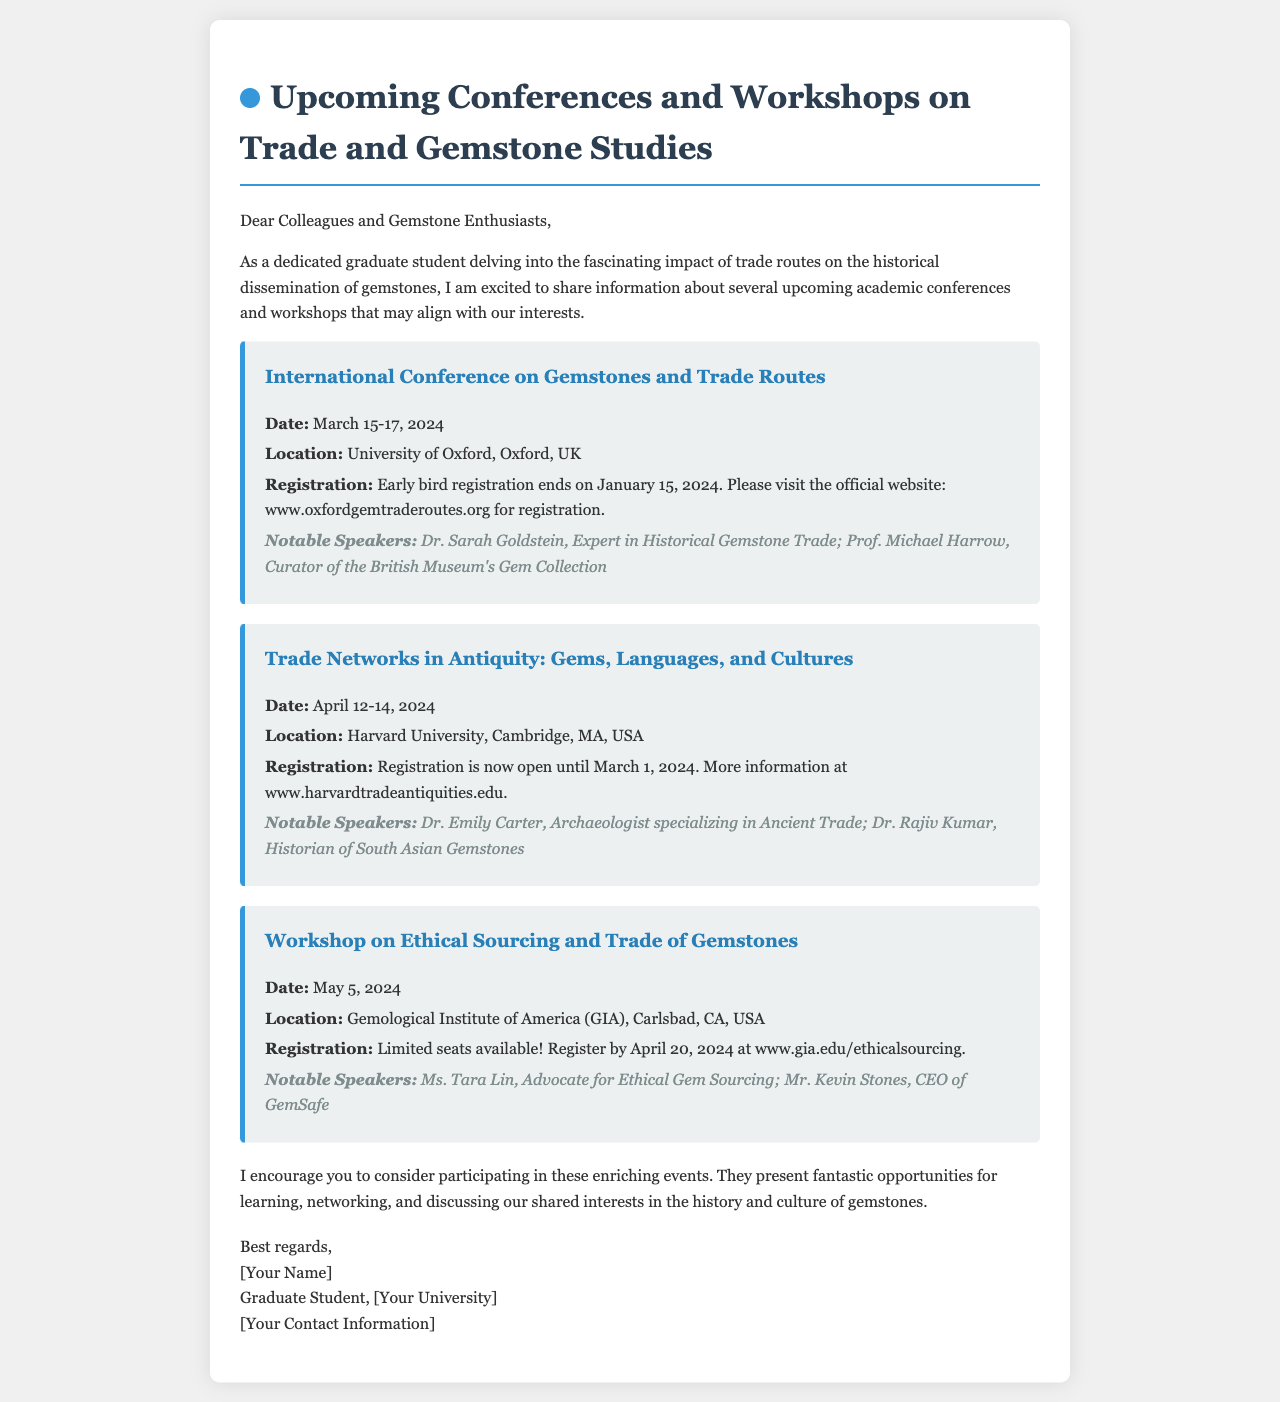What is the title of the first event? The title of the first event is directly mentioned in the document as the first heading under the events section.
Answer: International Conference on Gemstones and Trade Routes What are the dates for the workshop on ethical sourcing? The dates for the workshop are mentioned in the event details in the document.
Answer: May 5, 2024 Who is one of the notable speakers at the Harvard University event? The notable speakers for each event are listed in the document, specifically under the Harvard University event details.
Answer: Dr. Emily Carter When does early bird registration end for the first conference? The document explicitly states the date for the end of early bird registration for the first conference.
Answer: January 15, 2024 What university is hosting the workshop on ethical sourcing? The hosting location is specified under the event details in the document.
Answer: Gemological Institute of America (GIA) How many days is the International Conference on Gemstones and Trade Routes? The duration of the conference is provided in the date section of the event description.
Answer: 3 days Where is the Trade Networks in Antiquity event located? The location for the event is clearly mentioned in the document.
Answer: Harvard University, Cambridge, MA, USA What is stated as a reason to attend these events? The document contains a paragraph explaining the benefits of participating in these conferences and workshops.
Answer: Learning, networking, and discussing shared interests in the history and culture of gemstones 